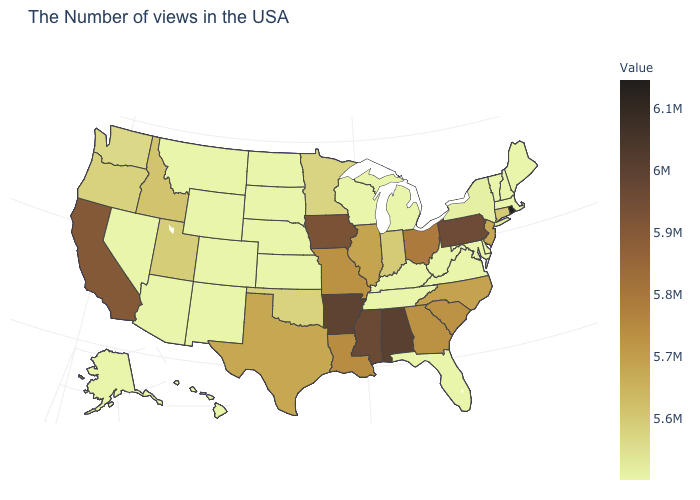Does Idaho have a higher value than Texas?
Give a very brief answer. No. Is the legend a continuous bar?
Short answer required. Yes. Is the legend a continuous bar?
Write a very short answer. Yes. Does the map have missing data?
Keep it brief. No. Among the states that border New Mexico , which have the highest value?
Keep it brief. Texas. Which states have the highest value in the USA?
Write a very short answer. Rhode Island. Among the states that border Washington , does Idaho have the lowest value?
Give a very brief answer. No. 